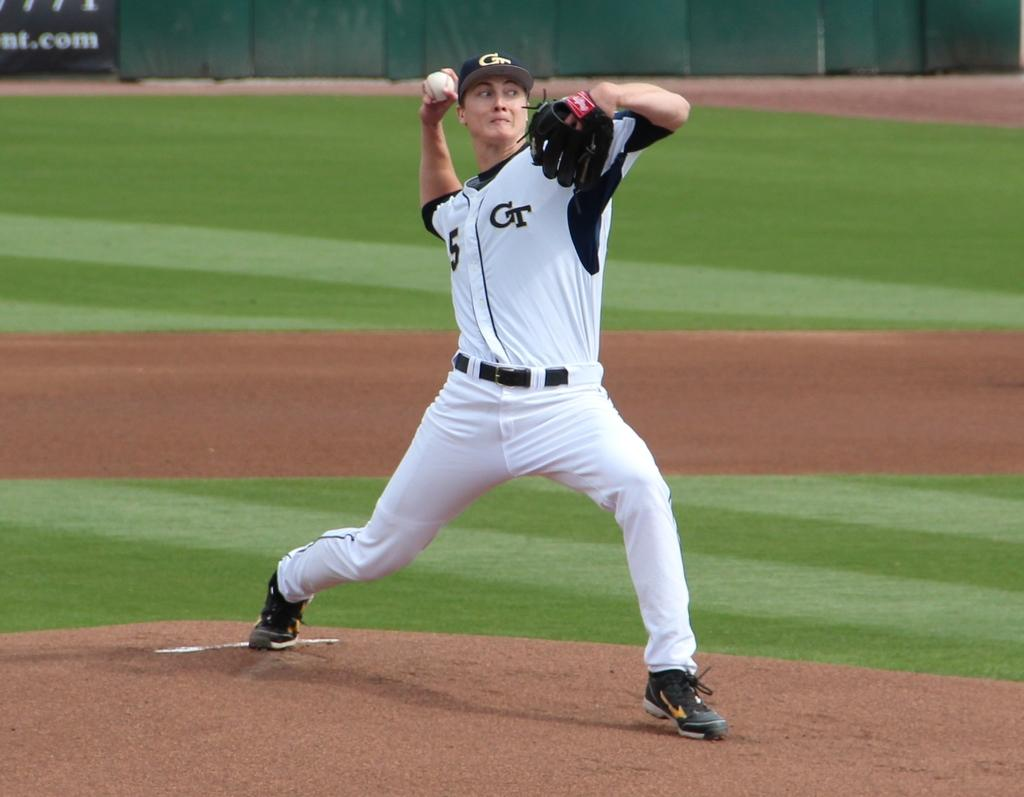Provide a one-sentence caption for the provided image. Player number 5 for team GT throws a pitch across the field. 